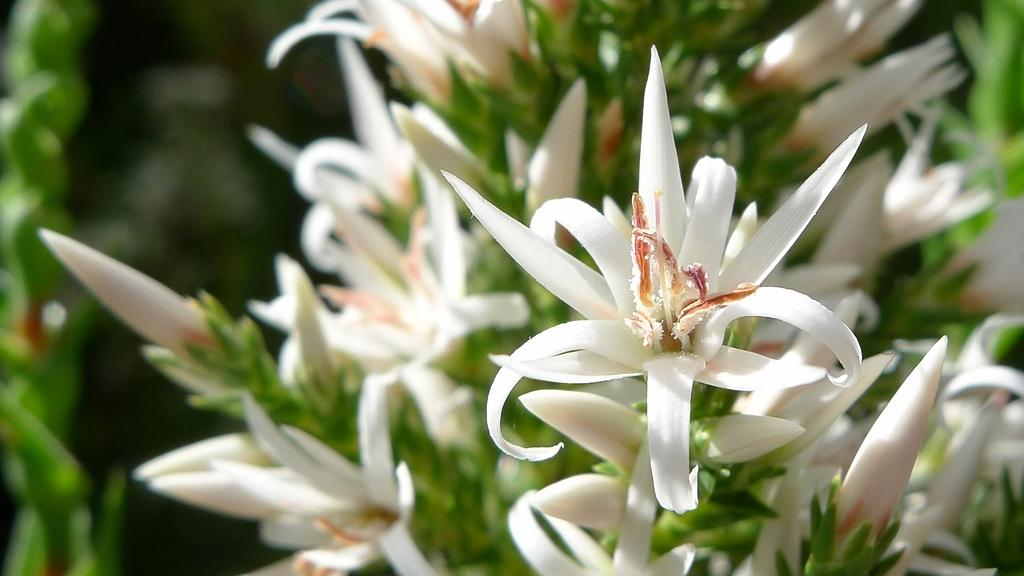What type of flowers can be seen in the image? There are white flowers in the image. What else can be seen in the background of the image? There are leaves in the background of the image. How would you describe the overall clarity of the image? The image is blurry. What type of jewel is hanging from the zephyr in the image? There is no jewel or zephyr present in the image; it features white flowers and leaves in the background. 